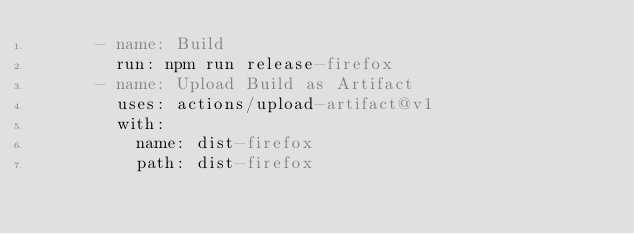Convert code to text. <code><loc_0><loc_0><loc_500><loc_500><_YAML_>      - name: Build
        run: npm run release-firefox
      - name: Upload Build as Artifact
        uses: actions/upload-artifact@v1
        with:
          name: dist-firefox
          path: dist-firefox
</code> 